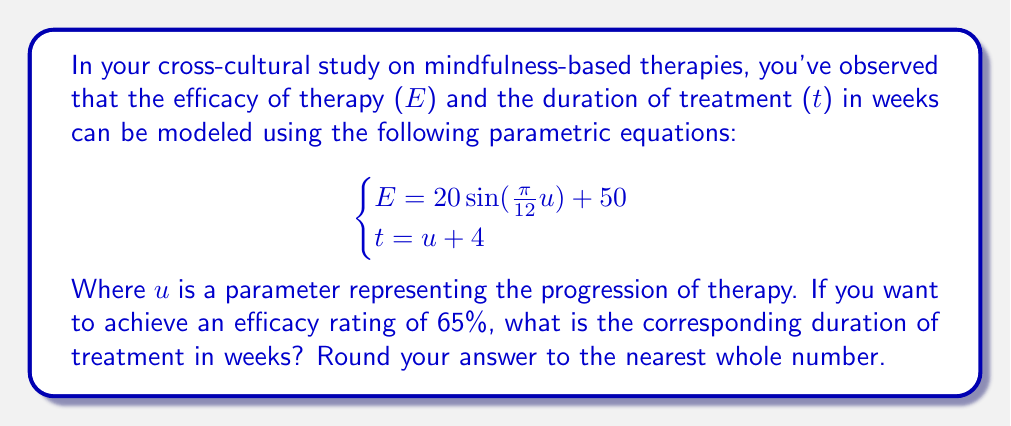Help me with this question. To solve this problem, we need to follow these steps:

1) We're looking for an efficacy rating of 65%, so we set $E = 65$ in the first equation:

   $$65 = 20\sin(\frac{\pi}{12}u) + 50$$

2) Subtract 50 from both sides:

   $$15 = 20\sin(\frac{\pi}{12}u)$$

3) Divide both sides by 20:

   $$0.75 = \sin(\frac{\pi}{12}u)$$

4) Take the inverse sine (arcsin) of both sides:

   $$\arcsin(0.75) = \frac{\pi}{12}u$$

5) Multiply both sides by $\frac{12}{\pi}$:

   $$\frac{12}{\pi}\arcsin(0.75) = u$$

6) Calculate the value of $u$:

   $$u \approx 9.2416$$

7) Now that we have $u$, we can use the second equation to find $t$:

   $$t = u + 4$$
   $$t = 9.2416 + 4 = 13.2416$$

8) Rounding to the nearest whole number:

   $$t \approx 13$$
Answer: 13 weeks 